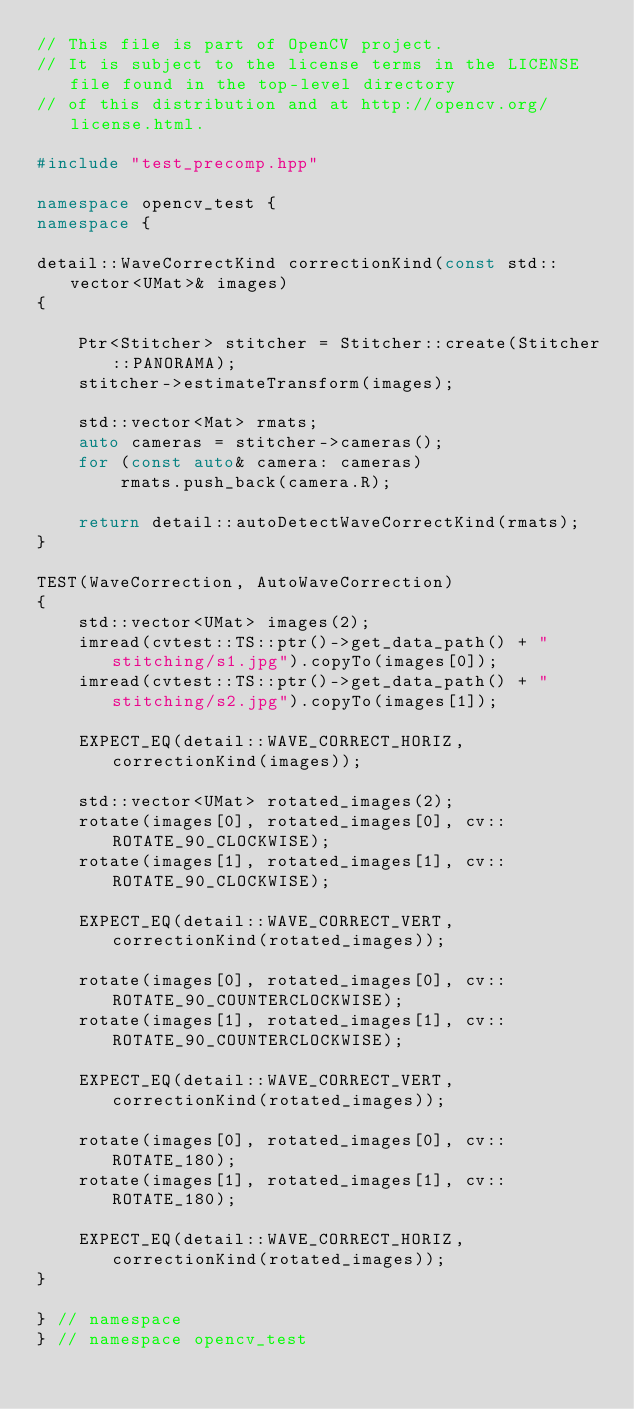<code> <loc_0><loc_0><loc_500><loc_500><_C++_>// This file is part of OpenCV project.
// It is subject to the license terms in the LICENSE file found in the top-level directory
// of this distribution and at http://opencv.org/license.html.

#include "test_precomp.hpp"

namespace opencv_test {
namespace {

detail::WaveCorrectKind correctionKind(const std::vector<UMat>& images)
{

    Ptr<Stitcher> stitcher = Stitcher::create(Stitcher::PANORAMA);
    stitcher->estimateTransform(images);

    std::vector<Mat> rmats;
    auto cameras = stitcher->cameras();
    for (const auto& camera: cameras)
        rmats.push_back(camera.R);

    return detail::autoDetectWaveCorrectKind(rmats);
}

TEST(WaveCorrection, AutoWaveCorrection)
{
    std::vector<UMat> images(2);
    imread(cvtest::TS::ptr()->get_data_path() + "stitching/s1.jpg").copyTo(images[0]);
    imread(cvtest::TS::ptr()->get_data_path() + "stitching/s2.jpg").copyTo(images[1]);

    EXPECT_EQ(detail::WAVE_CORRECT_HORIZ, correctionKind(images));

    std::vector<UMat> rotated_images(2);
    rotate(images[0], rotated_images[0], cv::ROTATE_90_CLOCKWISE);
    rotate(images[1], rotated_images[1], cv::ROTATE_90_CLOCKWISE);

    EXPECT_EQ(detail::WAVE_CORRECT_VERT, correctionKind(rotated_images));

    rotate(images[0], rotated_images[0], cv::ROTATE_90_COUNTERCLOCKWISE);
    rotate(images[1], rotated_images[1], cv::ROTATE_90_COUNTERCLOCKWISE);

    EXPECT_EQ(detail::WAVE_CORRECT_VERT, correctionKind(rotated_images));

    rotate(images[0], rotated_images[0], cv::ROTATE_180);
    rotate(images[1], rotated_images[1], cv::ROTATE_180);

    EXPECT_EQ(detail::WAVE_CORRECT_HORIZ, correctionKind(rotated_images));
}

} // namespace
} // namespace opencv_test
</code> 